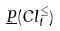Convert formula to latex. <formula><loc_0><loc_0><loc_500><loc_500>\underline { P } ( C l _ { t } ^ { \leq } )</formula> 